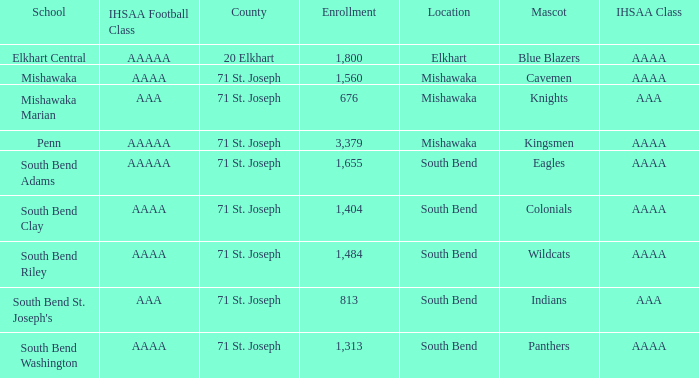Could you help me parse every detail presented in this table? {'header': ['School', 'IHSAA Football Class', 'County', 'Enrollment', 'Location', 'Mascot', 'IHSAA Class'], 'rows': [['Elkhart Central', 'AAAAA', '20 Elkhart', '1,800', 'Elkhart', 'Blue Blazers', 'AAAA'], ['Mishawaka', 'AAAA', '71 St. Joseph', '1,560', 'Mishawaka', 'Cavemen', 'AAAA'], ['Mishawaka Marian', 'AAA', '71 St. Joseph', '676', 'Mishawaka', 'Knights', 'AAA'], ['Penn', 'AAAAA', '71 St. Joseph', '3,379', 'Mishawaka', 'Kingsmen', 'AAAA'], ['South Bend Adams', 'AAAAA', '71 St. Joseph', '1,655', 'South Bend', 'Eagles', 'AAAA'], ['South Bend Clay', 'AAAA', '71 St. Joseph', '1,404', 'South Bend', 'Colonials', 'AAAA'], ['South Bend Riley', 'AAAA', '71 St. Joseph', '1,484', 'South Bend', 'Wildcats', 'AAAA'], ["South Bend St. Joseph's", 'AAA', '71 St. Joseph', '813', 'South Bend', 'Indians', 'AAA'], ['South Bend Washington', 'AAAA', '71 St. Joseph', '1,313', 'South Bend', 'Panthers', 'AAAA']]} What IHSAA Football Class has 20 elkhart as the county? AAAAA. 